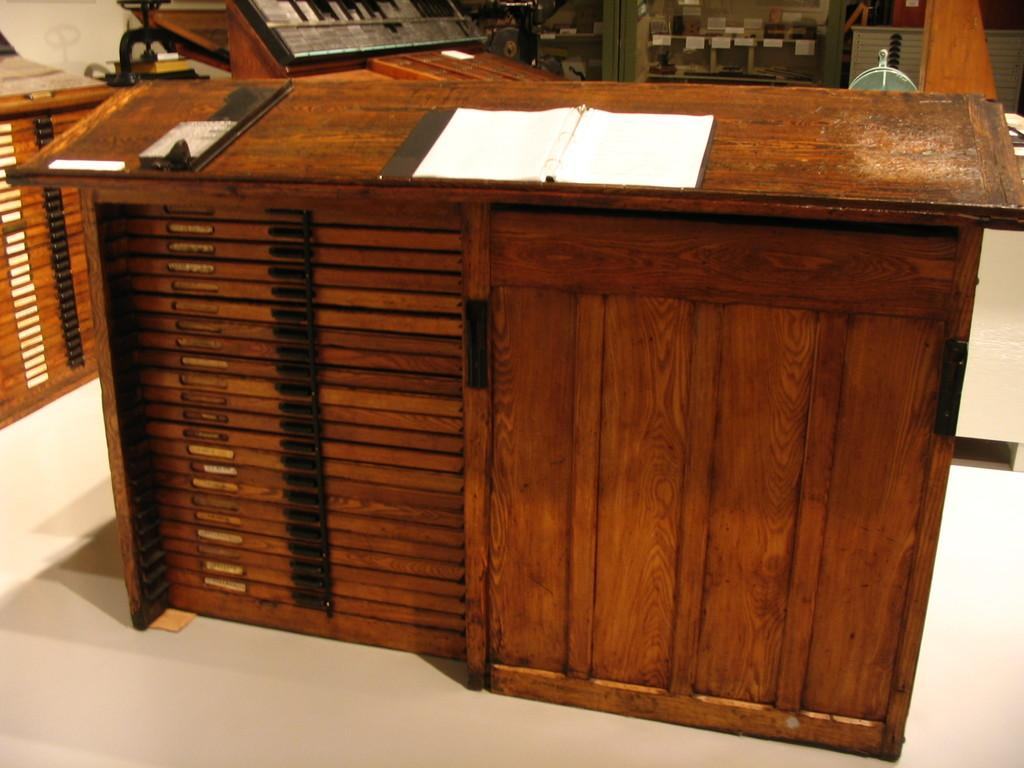What piece of furniture is present in the image? There is a table in the image. What object is placed on the table? There is a book on the table. What type of boundary is visible in the image? There is no boundary present in the image. How many cubs can be seen interacting with the stone in the image? There are no cubs or stones present in the image. 